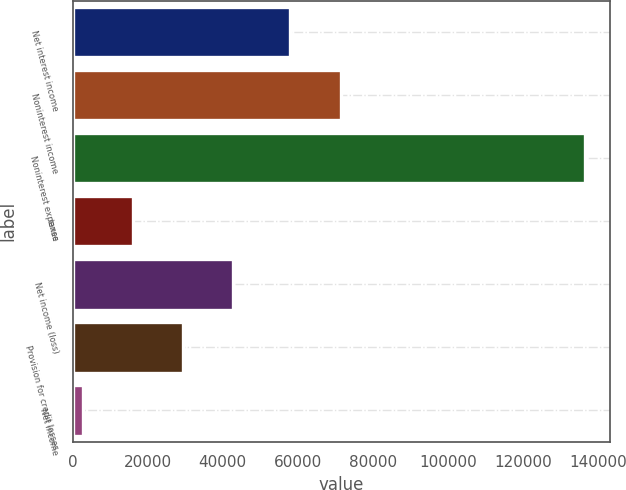Convert chart. <chart><loc_0><loc_0><loc_500><loc_500><bar_chart><fcel>Net interest income<fcel>Noninterest income<fcel>Noninterest expense<fcel>taxes<fcel>Net income (loss)<fcel>Provision for credit losses<fcel>Net income<nl><fcel>58015<fcel>71385.4<fcel>136374<fcel>16040.4<fcel>42781.2<fcel>29410.8<fcel>2670<nl></chart> 